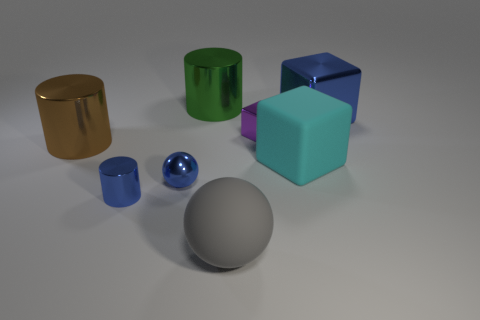The blue shiny cylinder has what size?
Keep it short and to the point. Small. Is the big block that is left of the large blue metal object made of the same material as the blue sphere?
Give a very brief answer. No. What number of yellow blocks are there?
Provide a short and direct response. 0. How many objects are large rubber blocks or purple objects?
Ensure brevity in your answer.  2. There is a big rubber object right of the big sphere that is on the left side of the purple metal object; what number of small blue metallic spheres are on the right side of it?
Keep it short and to the point. 0. Is there anything else that is the same color as the big matte cube?
Give a very brief answer. No. Does the matte thing behind the gray sphere have the same color as the tiny thing that is in front of the blue metal sphere?
Give a very brief answer. No. Is the number of green shiny objects behind the gray matte object greater than the number of tiny blue spheres to the right of the cyan rubber cube?
Ensure brevity in your answer.  Yes. What is the material of the big green cylinder?
Your answer should be compact. Metal. What shape is the matte object that is behind the sphere on the right side of the big metallic cylinder on the right side of the blue shiny ball?
Offer a terse response. Cube. 